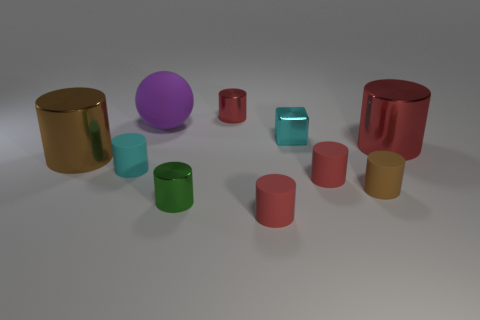What is the size of the object that is the same color as the block?
Your answer should be very brief. Small. Do the large rubber object and the tiny block have the same color?
Your response must be concise. No. How many tiny cyan objects are the same shape as the large purple rubber object?
Give a very brief answer. 0. Does the tiny cyan matte thing have the same shape as the rubber thing that is behind the big red cylinder?
Give a very brief answer. No. What shape is the matte thing that is the same color as the tiny shiny cube?
Offer a very short reply. Cylinder. Is there a big brown cylinder made of the same material as the small cyan cylinder?
Provide a short and direct response. No. Are there any other things that are made of the same material as the small green cylinder?
Offer a very short reply. Yes. There is a cyan object on the left side of the rubber cylinder in front of the tiny green thing; what is its material?
Make the answer very short. Rubber. There is a metal cylinder that is to the left of the small green metal thing in front of the brown cylinder that is on the left side of the cyan metal thing; what is its size?
Your response must be concise. Large. How many other things are the same shape as the purple matte thing?
Ensure brevity in your answer.  0. 